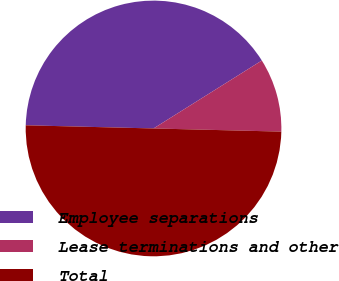<chart> <loc_0><loc_0><loc_500><loc_500><pie_chart><fcel>Employee separations<fcel>Lease terminations and other<fcel>Total<nl><fcel>40.69%<fcel>9.31%<fcel>50.0%<nl></chart> 